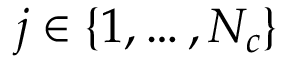Convert formula to latex. <formula><loc_0><loc_0><loc_500><loc_500>j \in \left \{ 1 , \dots , N _ { c } \right \}</formula> 